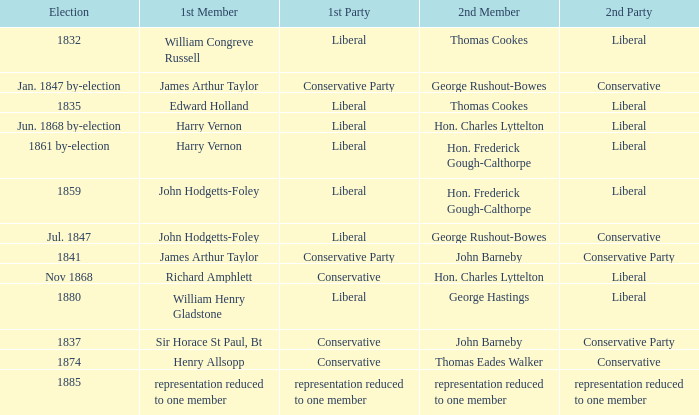What was the 1st Member when the 1st Party had its representation reduced to one member? Representation reduced to one member. 